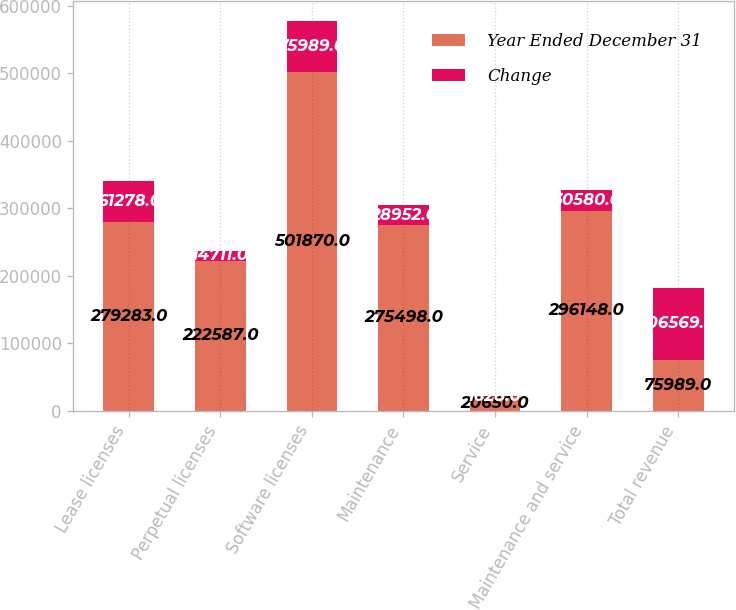Convert chart to OTSL. <chart><loc_0><loc_0><loc_500><loc_500><stacked_bar_chart><ecel><fcel>Lease licenses<fcel>Perpetual licenses<fcel>Software licenses<fcel>Maintenance<fcel>Service<fcel>Maintenance and service<fcel>Total revenue<nl><fcel>Year Ended December 31<fcel>279283<fcel>222587<fcel>501870<fcel>275498<fcel>20650<fcel>296148<fcel>75989<nl><fcel>Change<fcel>61278<fcel>14711<fcel>75989<fcel>28952<fcel>1628<fcel>30580<fcel>106569<nl></chart> 